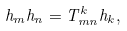Convert formula to latex. <formula><loc_0><loc_0><loc_500><loc_500>h _ { m } h _ { n } = T _ { m n } ^ { k } h _ { k } ,</formula> 